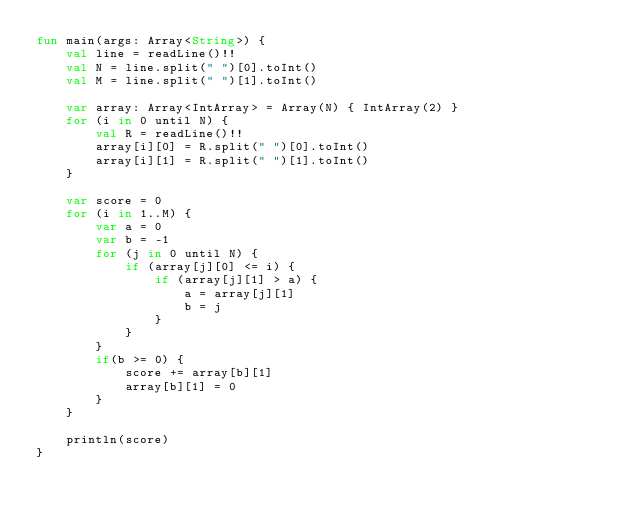Convert code to text. <code><loc_0><loc_0><loc_500><loc_500><_Kotlin_>fun main(args: Array<String>) {
    val line = readLine()!!
    val N = line.split(" ")[0].toInt()
    val M = line.split(" ")[1].toInt()

    var array: Array<IntArray> = Array(N) { IntArray(2) }
    for (i in 0 until N) {
        val R = readLine()!!
        array[i][0] = R.split(" ")[0].toInt()
        array[i][1] = R.split(" ")[1].toInt()
    }

    var score = 0
    for (i in 1..M) {
        var a = 0
        var b = -1
        for (j in 0 until N) {
            if (array[j][0] <= i) {
                if (array[j][1] > a) {
                    a = array[j][1]
                    b = j
                }
            }
        }
        if(b >= 0) {
            score += array[b][1]
            array[b][1] = 0
        }
    }

    println(score)
}</code> 